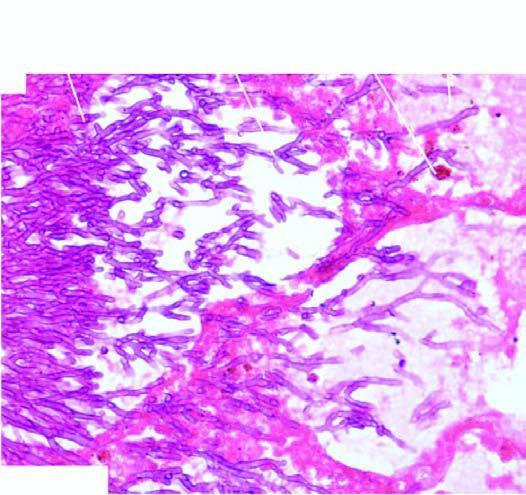re the opened up inner surface of the abdominal aorta best identified with a special stain for fungi, gomory 's methenamine silver gms?
Answer the question using a single word or phrase. No 